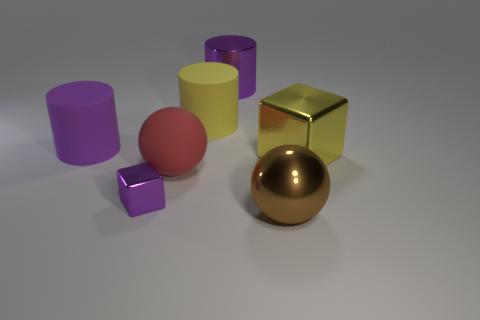The purple thing that is made of the same material as the red sphere is what shape?
Your answer should be very brief. Cylinder. How many tiny things are metal things or yellow objects?
Give a very brief answer. 1. How many other objects are there of the same color as the large cube?
Your answer should be very brief. 1. What number of small objects are left of the purple thing that is in front of the big purple matte cylinder behind the small metal object?
Ensure brevity in your answer.  0. There is a purple object behind the purple matte cylinder; is it the same size as the purple rubber cylinder?
Ensure brevity in your answer.  Yes. Is the number of yellow matte cylinders behind the purple metal cylinder less than the number of big matte objects on the left side of the purple cube?
Your answer should be very brief. Yes. Does the large block have the same color as the small metal cube?
Provide a short and direct response. No. Are there fewer large balls that are to the left of the large yellow cylinder than yellow objects?
Provide a short and direct response. Yes. There is a big object that is the same color as the metal cylinder; what is its material?
Make the answer very short. Rubber. Does the tiny purple block have the same material as the large brown ball?
Keep it short and to the point. Yes. 